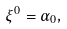Convert formula to latex. <formula><loc_0><loc_0><loc_500><loc_500>\xi ^ { 0 } = \alpha _ { 0 } ,</formula> 